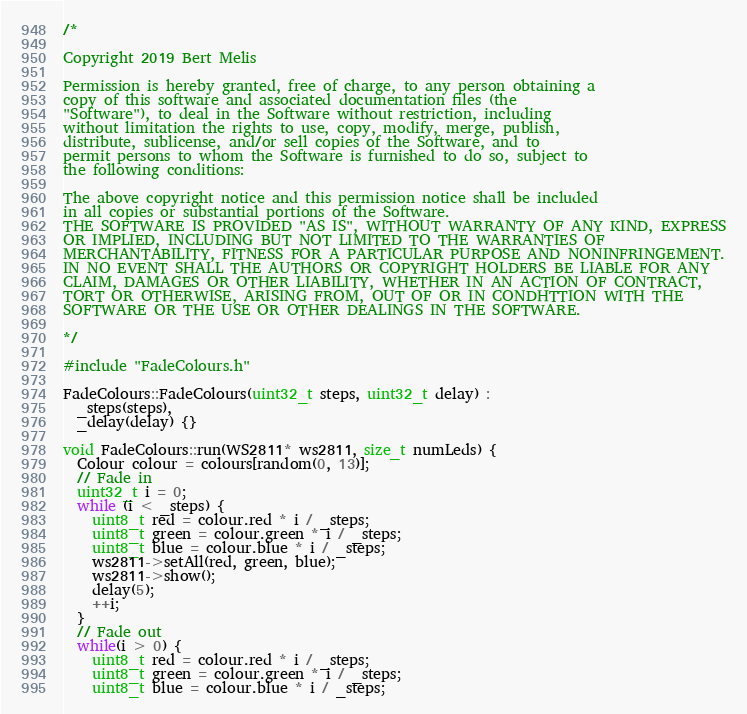Convert code to text. <code><loc_0><loc_0><loc_500><loc_500><_C++_>/*

Copyright 2019 Bert Melis

Permission is hereby granted, free of charge, to any person obtaining a
copy of this software and associated documentation files (the
"Software"), to deal in the Software without restriction, including
without limitation the rights to use, copy, modify, merge, publish,
distribute, sublicense, and/or sell copies of the Software, and to
permit persons to whom the Software is furnished to do so, subject to
the following conditions:

The above copyright notice and this permission notice shall be included
in all copies or substantial portions of the Software.
THE SOFTWARE IS PROVIDED "AS IS", WITHOUT WARRANTY OF ANY KIND, EXPRESS
OR IMPLIED, INCLUDING BUT NOT LIMITED TO THE WARRANTIES OF
MERCHANTABILITY, FITNESS FOR A PARTICULAR PURPOSE AND NONINFRINGEMENT.
IN NO EVENT SHALL THE AUTHORS OR COPYRIGHT HOLDERS BE LIABLE FOR ANY
CLAIM, DAMAGES OR OTHER LIABILITY, WHETHER IN AN ACTION OF CONTRACT,
TORT OR OTHERWISE, ARISING FROM, OUT OF OR IN CONDHTTION WITH THE
SOFTWARE OR THE USE OR OTHER DEALINGS IN THE SOFTWARE.

*/

#include "FadeColours.h"

FadeColours::FadeColours(uint32_t steps, uint32_t delay) :
  _steps(steps),
  _delay(delay) {}

void FadeColours::run(WS2811* ws2811, size_t numLeds) {
  Colour colour = colours[random(0, 13)];
  // Fade in
  uint32_t i = 0;
  while (i < _steps) {
    uint8_t red = colour.red * i / _steps;
    uint8_t green = colour.green * i / _steps;
    uint8_t blue = colour.blue * i / _steps;
    ws2811->setAll(red, green, blue);
    ws2811->show();
    delay(5);
    ++i;
  }
  // Fade out
  while(i > 0) {
    uint8_t red = colour.red * i / _steps;
    uint8_t green = colour.green * i / _steps;
    uint8_t blue = colour.blue * i / _steps;</code> 